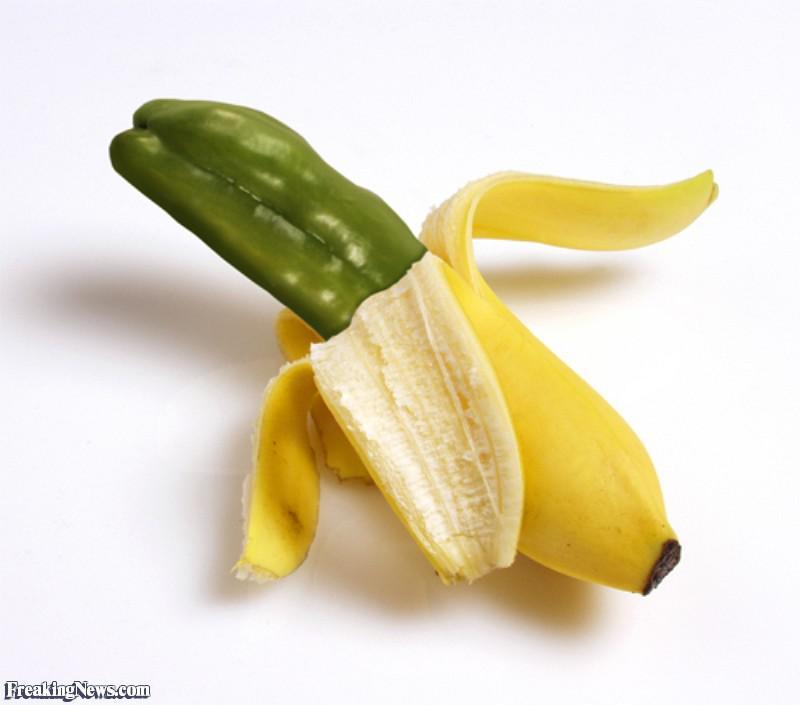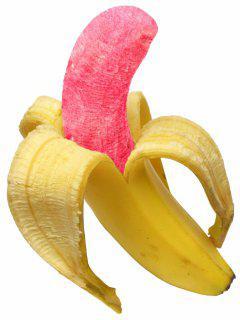The first image is the image on the left, the second image is the image on the right. Analyze the images presented: Is the assertion "The combined images include a pink-fleshed banana and a banana peel that resembles a different type of fruit." valid? Answer yes or no. No. 